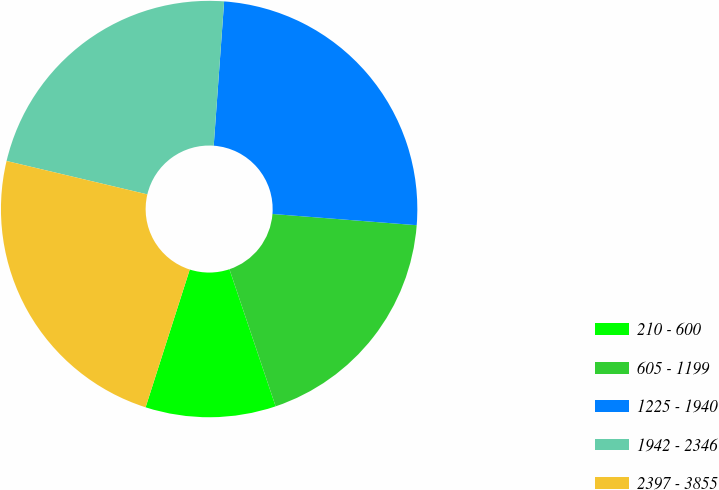Convert chart. <chart><loc_0><loc_0><loc_500><loc_500><pie_chart><fcel>210 - 600<fcel>605 - 1199<fcel>1225 - 1940<fcel>1942 - 2346<fcel>2397 - 3855<nl><fcel>10.11%<fcel>18.59%<fcel>25.09%<fcel>22.44%<fcel>23.77%<nl></chart> 